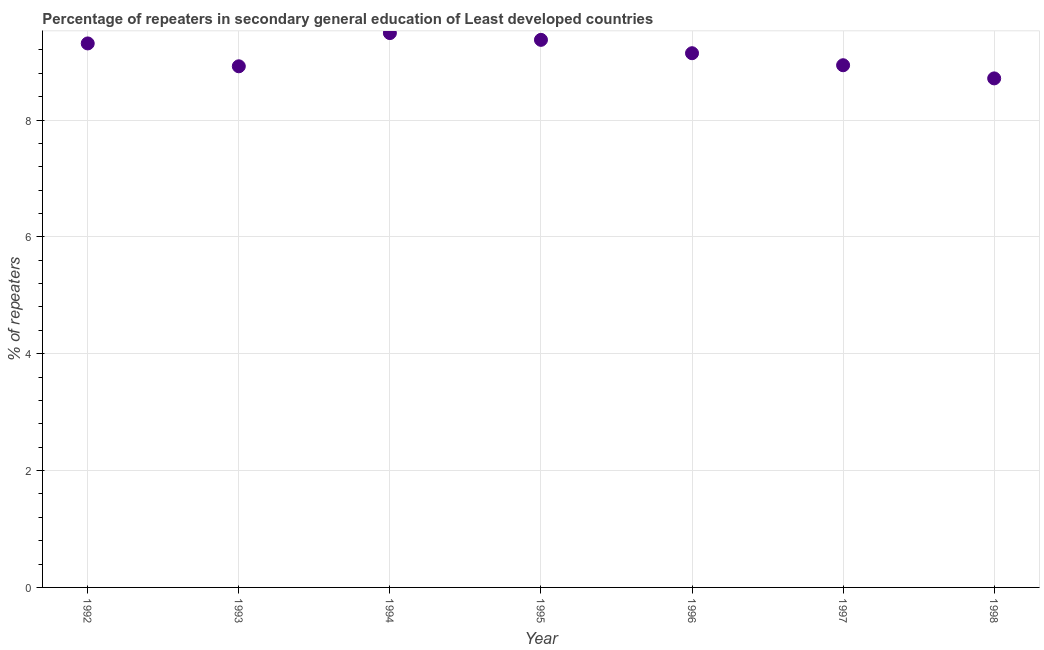What is the percentage of repeaters in 1996?
Provide a succinct answer. 9.14. Across all years, what is the maximum percentage of repeaters?
Your answer should be compact. 9.49. Across all years, what is the minimum percentage of repeaters?
Provide a short and direct response. 8.71. In which year was the percentage of repeaters minimum?
Give a very brief answer. 1998. What is the sum of the percentage of repeaters?
Offer a very short reply. 63.88. What is the difference between the percentage of repeaters in 1995 and 1998?
Your response must be concise. 0.66. What is the average percentage of repeaters per year?
Provide a short and direct response. 9.13. What is the median percentage of repeaters?
Your answer should be compact. 9.14. In how many years, is the percentage of repeaters greater than 6.8 %?
Offer a very short reply. 7. Do a majority of the years between 1998 and 1995 (inclusive) have percentage of repeaters greater than 3.6 %?
Your answer should be compact. Yes. What is the ratio of the percentage of repeaters in 1992 to that in 1994?
Your answer should be compact. 0.98. Is the percentage of repeaters in 1994 less than that in 1998?
Provide a short and direct response. No. What is the difference between the highest and the second highest percentage of repeaters?
Keep it short and to the point. 0.12. What is the difference between the highest and the lowest percentage of repeaters?
Provide a short and direct response. 0.78. In how many years, is the percentage of repeaters greater than the average percentage of repeaters taken over all years?
Provide a succinct answer. 4. Does the percentage of repeaters monotonically increase over the years?
Give a very brief answer. No. How many dotlines are there?
Your response must be concise. 1. How many years are there in the graph?
Provide a short and direct response. 7. Does the graph contain any zero values?
Your answer should be compact. No. Does the graph contain grids?
Your answer should be compact. Yes. What is the title of the graph?
Ensure brevity in your answer.  Percentage of repeaters in secondary general education of Least developed countries. What is the label or title of the X-axis?
Offer a terse response. Year. What is the label or title of the Y-axis?
Provide a succinct answer. % of repeaters. What is the % of repeaters in 1992?
Ensure brevity in your answer.  9.31. What is the % of repeaters in 1993?
Provide a succinct answer. 8.92. What is the % of repeaters in 1994?
Your answer should be very brief. 9.49. What is the % of repeaters in 1995?
Ensure brevity in your answer.  9.37. What is the % of repeaters in 1996?
Your answer should be compact. 9.14. What is the % of repeaters in 1997?
Your response must be concise. 8.94. What is the % of repeaters in 1998?
Keep it short and to the point. 8.71. What is the difference between the % of repeaters in 1992 and 1993?
Provide a succinct answer. 0.39. What is the difference between the % of repeaters in 1992 and 1994?
Your answer should be compact. -0.18. What is the difference between the % of repeaters in 1992 and 1995?
Your response must be concise. -0.06. What is the difference between the % of repeaters in 1992 and 1996?
Make the answer very short. 0.17. What is the difference between the % of repeaters in 1992 and 1997?
Your answer should be compact. 0.37. What is the difference between the % of repeaters in 1992 and 1998?
Offer a terse response. 0.6. What is the difference between the % of repeaters in 1993 and 1994?
Provide a succinct answer. -0.57. What is the difference between the % of repeaters in 1993 and 1995?
Provide a succinct answer. -0.45. What is the difference between the % of repeaters in 1993 and 1996?
Your response must be concise. -0.22. What is the difference between the % of repeaters in 1993 and 1997?
Give a very brief answer. -0.02. What is the difference between the % of repeaters in 1993 and 1998?
Your response must be concise. 0.21. What is the difference between the % of repeaters in 1994 and 1995?
Provide a succinct answer. 0.12. What is the difference between the % of repeaters in 1994 and 1996?
Make the answer very short. 0.34. What is the difference between the % of repeaters in 1994 and 1997?
Provide a short and direct response. 0.55. What is the difference between the % of repeaters in 1994 and 1998?
Offer a terse response. 0.78. What is the difference between the % of repeaters in 1995 and 1996?
Make the answer very short. 0.23. What is the difference between the % of repeaters in 1995 and 1997?
Make the answer very short. 0.43. What is the difference between the % of repeaters in 1995 and 1998?
Offer a very short reply. 0.66. What is the difference between the % of repeaters in 1996 and 1997?
Give a very brief answer. 0.21. What is the difference between the % of repeaters in 1996 and 1998?
Offer a terse response. 0.43. What is the difference between the % of repeaters in 1997 and 1998?
Provide a short and direct response. 0.23. What is the ratio of the % of repeaters in 1992 to that in 1993?
Offer a terse response. 1.04. What is the ratio of the % of repeaters in 1992 to that in 1994?
Give a very brief answer. 0.98. What is the ratio of the % of repeaters in 1992 to that in 1995?
Offer a very short reply. 0.99. What is the ratio of the % of repeaters in 1992 to that in 1996?
Your answer should be very brief. 1.02. What is the ratio of the % of repeaters in 1992 to that in 1997?
Your response must be concise. 1.04. What is the ratio of the % of repeaters in 1992 to that in 1998?
Keep it short and to the point. 1.07. What is the ratio of the % of repeaters in 1994 to that in 1995?
Your answer should be very brief. 1.01. What is the ratio of the % of repeaters in 1994 to that in 1996?
Ensure brevity in your answer.  1.04. What is the ratio of the % of repeaters in 1994 to that in 1997?
Offer a very short reply. 1.06. What is the ratio of the % of repeaters in 1994 to that in 1998?
Keep it short and to the point. 1.09. What is the ratio of the % of repeaters in 1995 to that in 1996?
Offer a terse response. 1.02. What is the ratio of the % of repeaters in 1995 to that in 1997?
Offer a terse response. 1.05. What is the ratio of the % of repeaters in 1995 to that in 1998?
Provide a short and direct response. 1.08. What is the ratio of the % of repeaters in 1996 to that in 1997?
Offer a terse response. 1.02. What is the ratio of the % of repeaters in 1996 to that in 1998?
Your response must be concise. 1.05. What is the ratio of the % of repeaters in 1997 to that in 1998?
Your answer should be compact. 1.03. 